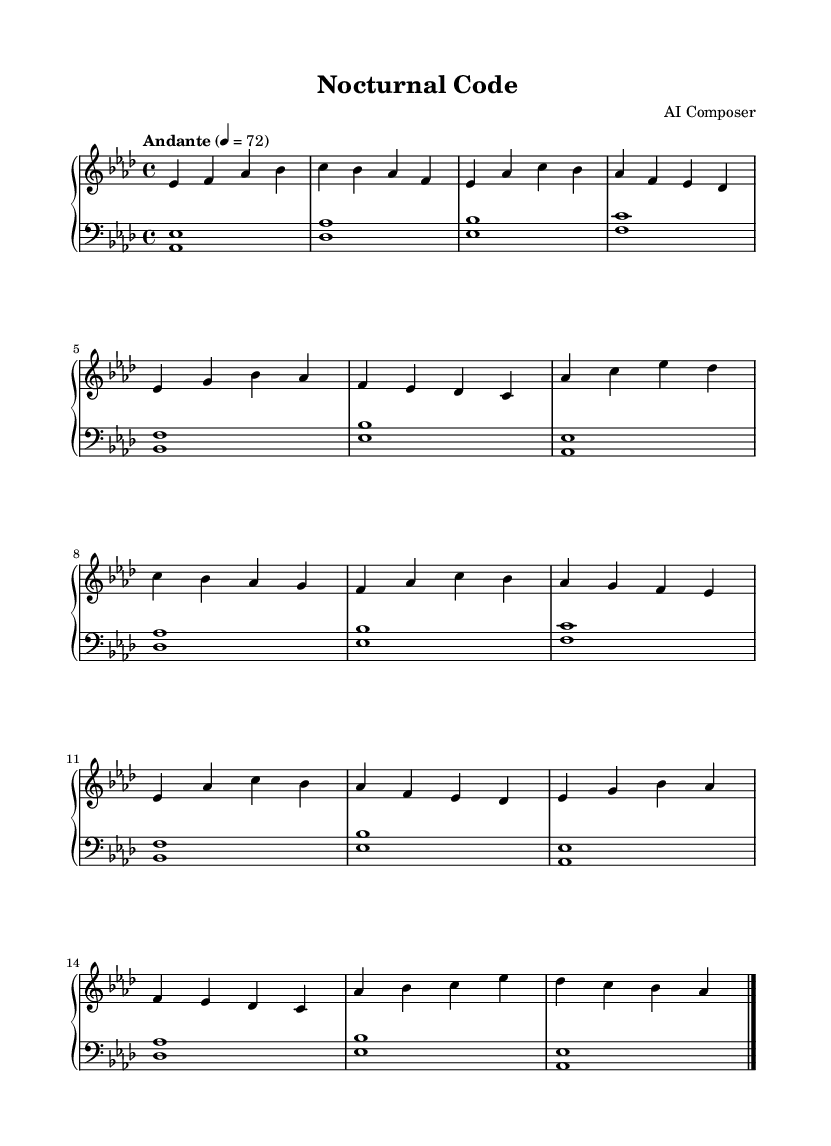What is the key signature of this music? The key signature is indicated by the symbols placed at the beginning of the staff. Here, there are three flats, which corresponds to the key of A-flat major.
Answer: A-flat major What is the time signature of this composition? The time signature is shown at the beginning of the staff with the fraction 4/4, meaning there are four beats in a measure and the quarter note gets one beat.
Answer: 4/4 What is the tempo marking for the piece? The tempo marking "Andante" is located above the staff, indicating a moderate pace, traditionally around 76 to 108 beats per minute. In this case, it specifically states 4 equals 72, designating 72 beats per minute.
Answer: Andante How many sections does the music consist of? By analyzing the structure, the music has three distinct sections: an A section, a B section, and a Coda. The A section appears twice (A and A'), totaling four sections overall.
Answer: Four What is the significance of the use of broken chords in the lower staff? The broken chords in the lower staff provide harmonic support and a sense of rhythm through a repeated pattern, which is characteristic of Romantic piano music, enhancing the overall smoothness and fluidity of the piece.
Answer: Harmonic support What notes are prominently featured in the B section? In the B section, the melody prominently features the pitches A, C, E-flat, and G, which create a contrast to the other sections and accentuate emotional phrasing typical in Romantic pieces.
Answer: A, C, E-flat, G Which melodic elements give the piece its soothing quality? Melodic elements such as flowing arpeggios, gentle dynamics, and the use of legato articulations contribute to the soothing quality, characteristic of Romantic melodies intended to evoke emotion and reflection.
Answer: Flowing arpeggios, legato 